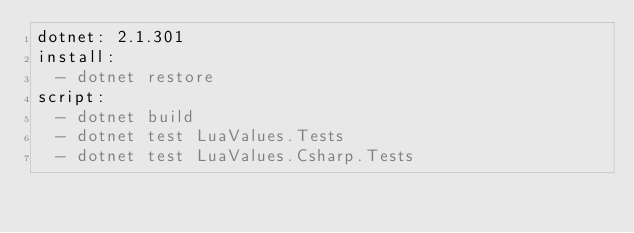Convert code to text. <code><loc_0><loc_0><loc_500><loc_500><_YAML_>dotnet: 2.1.301
install:
  - dotnet restore
script:
  - dotnet build
  - dotnet test LuaValues.Tests
  - dotnet test LuaValues.Csharp.Tests
</code> 